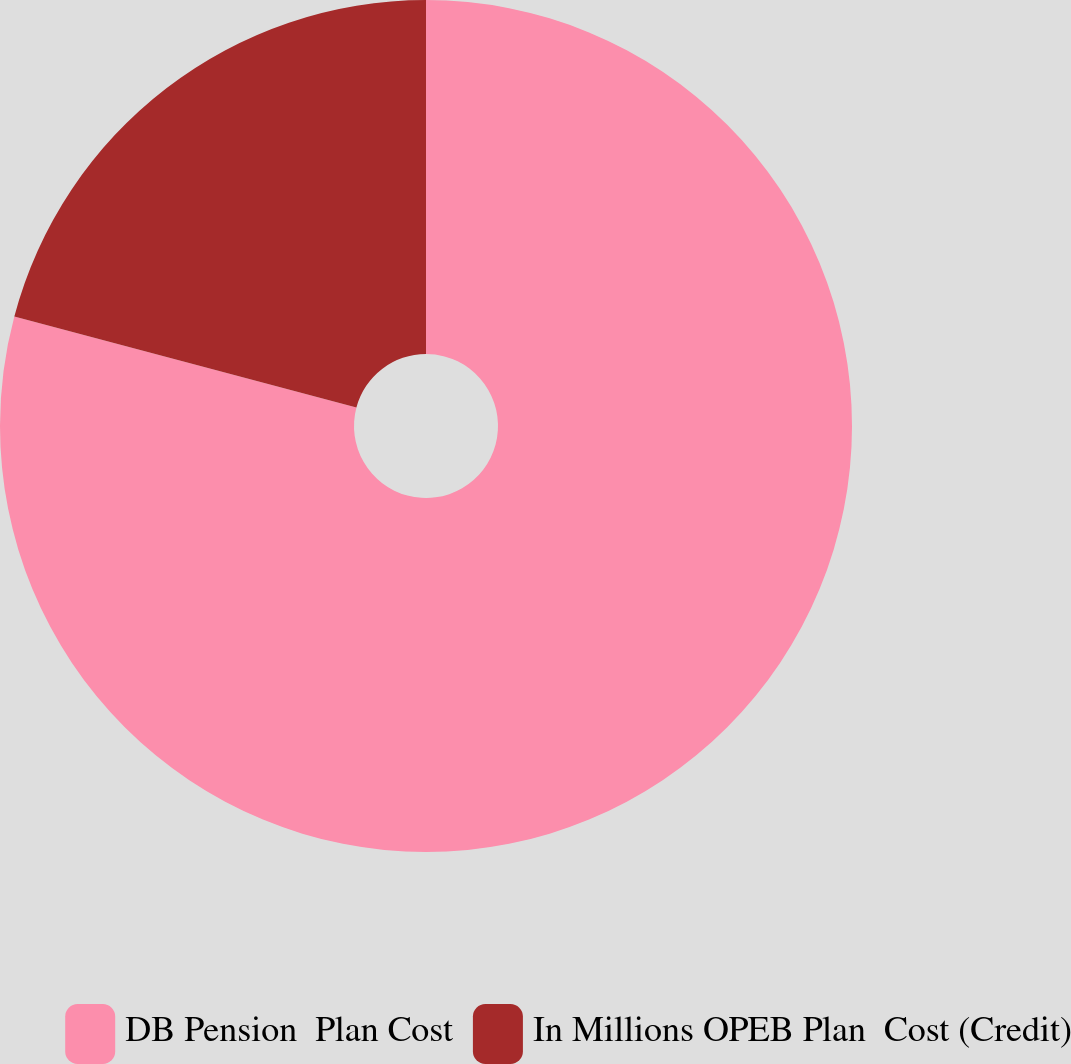<chart> <loc_0><loc_0><loc_500><loc_500><pie_chart><fcel>DB Pension  Plan Cost<fcel>In Millions OPEB Plan  Cost (Credit)<nl><fcel>79.14%<fcel>20.86%<nl></chart> 